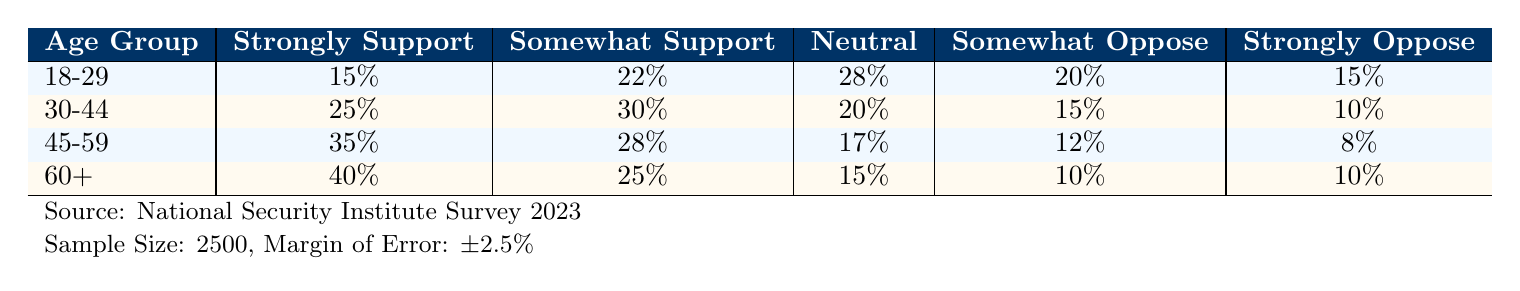What percentage of the 30-44 age group strongly supports increased military spending? In the table, under the 30-44 age group, the percentage for "Strongly Support" is listed as 25%.
Answer: 25% Which age group has the highest percentage of individuals who strongly oppose increased military spending? By examining the table, the highest percentage of "Strongly Oppose" is 10%, which is the same for the 30-44 and 60+ age groups. However, considering the lowest overall support, the 60+ group is notable for its significant support and equal opposition levels.
Answer: 30-44 and 60+ age groups What is the total percentage of the 45-59 age group that supports increased military spending (both strongly and somewhat)? Adding the "Strongly Support" (35%) and "Somewhat Support" (28%) together gives 35% + 28% = 63% for the 45-59 age group.
Answer: 63% Is the percentage of individuals aged 18-29 who are neutral greater than those who somewhat oppose increased military spending? The neutral percentage for the 18-29 age group is 28%, and the somewhat oppose group is 20%. Since 28% is greater than 20%, the statement is true.
Answer: Yes Which age group has the most individuals identifying as neutral towards increased military spending when comparing the four age groups? The neutral percentage for the 18-29 age group is 28%, while the other groups have percentages of 20%, 17%, and 15%. Since 28% is the highest, the 18-29 age group has the most neutrals.
Answer: 18-29 What is the difference in the percentage of support between those who strongly support and those who strongly oppose military spending in the 60+ age group? The "Strongly Support" percentage for 60+ is 40% and the "Strongly Oppose" is 10%. The difference is calculated as 40% - 10% = 30%.
Answer: 30% If we combine the somewhat support and strongly support percentages for all age groups, what is the total? For the combined percentages: (Strongly Support for all age groups: 15% + 25% + 35% + 40% = 115%) and (Somewhat Support for all age groups: 22% + 30% + 28% + 25% = 105%). Adding both yields 115% + 105% = 220%.
Answer: 220% True or False: The percentage of individuals aged 45-59 who oppose military spending (somewhat and strongly) is less than those who support it (somewhat and strongly). The summed percentages for opposition in the 45-59 age group are 12% (somewhat) + 8% (strongly) = 20%, and for support, they are 35% (strongly) + 28% (somewhat) = 63%. Since 20% < 63%, the statement is true.
Answer: True Calculate the overall average percentage of support across all age groups for military spending. The average percentage of support is calculated as (15% + 25% + 35% + 40% + 22% + 30% + 28% + 25%) / 8 = 25%.
Answer: 25% What age group shows a transition from majority support to majority opposition when analyses on a larger scale? The 18-29 age group includes both support and opposition percentages that are close, but the shift is evident in the 30-44 group where a higher proportion is in somewhat and strongly supportive categories compared to higher opposition in older age groups.
Answer: 45-59 and 60+ age groups 